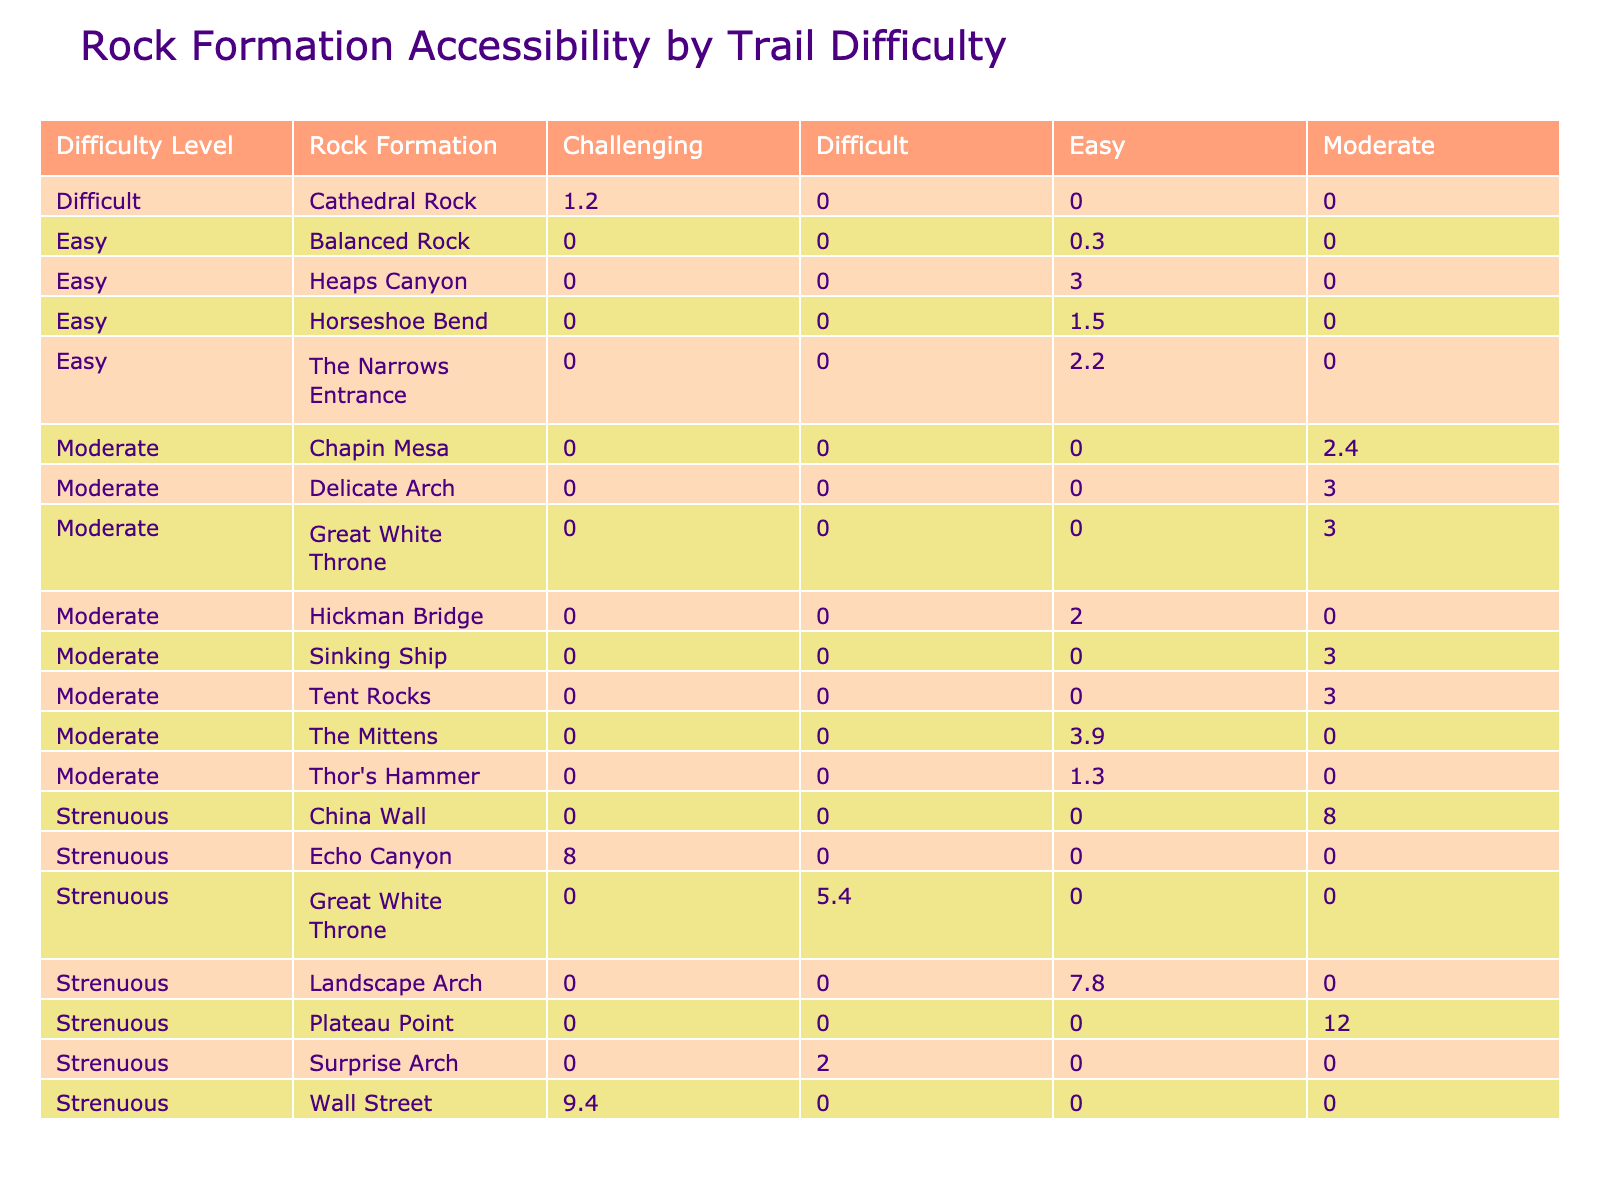What is the distance of the Delicate Arch Trail? The table indicates the distance associated with the Delicate Arch Trail listed under the "Distance (miles)" column, which is 3 miles.
Answer: 3 miles Which rock formation is accessible from the easiest trail? By checking the "Accessibility" column for the "Easy" category, we find that the Heaps Canyon rock formation is accessible from the Emerald Pools Trail.
Answer: Heaps Canyon What is the total distance of the trails with a "Strenuous" difficulty level? The distance for each strenuous trail is: 7.8 (Devil's Garden Loop) + 9.4 (The Narrows) + 5.4 (Angels Landing) + 12 (Bright Angel Trail) + 8 (Observation Point) + 8 (Fairyland Loop) + 2 (Fiery Furnace). Adding these distances gives us a total of 52.6 miles.
Answer: 52.6 miles Are there any trails classified as "Difficult" that provide easy accessibility? No, based on the table, the only "Difficult" trail, Cathedral Rock Trail, falls under "Challenging" accessibility.
Answer: No What is the average distance for trails that have "Moderate" difficulty? The distances for Moderate difficulty trails are: 3 (Delicate Arch Trail) + 1.3 (Navajo Loop) + 3 (Hidden Canyon Trail) + 3 (Grand View Trail) + 3.9 (Wildcat Trail) + 2.4 (Petroglyph Point Trail) + 3 (Tent Rocks Trail), which sums to 16.6 miles. There are 7 such trails, so average distance = 16.6 / 7 = 2.37 miles.
Answer: 2.37 miles How many trails have "Moderate" accessibility and "Strenuous" difficulty? In the table, we see that the trails with "Strenuous" difficulty have the accessibility of Moderate for the following trails: Plateau Point and China Wall, totaling 2 trails.
Answer: 2 trails 